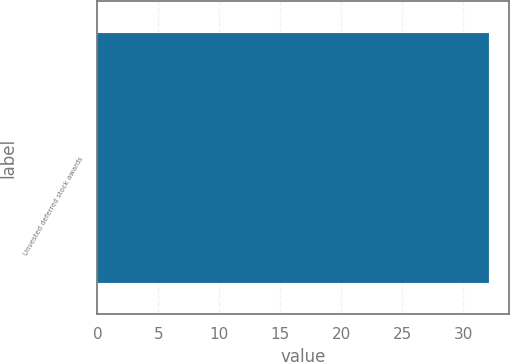<chart> <loc_0><loc_0><loc_500><loc_500><bar_chart><fcel>Unvested deferred stock awards<nl><fcel>32.12<nl></chart> 